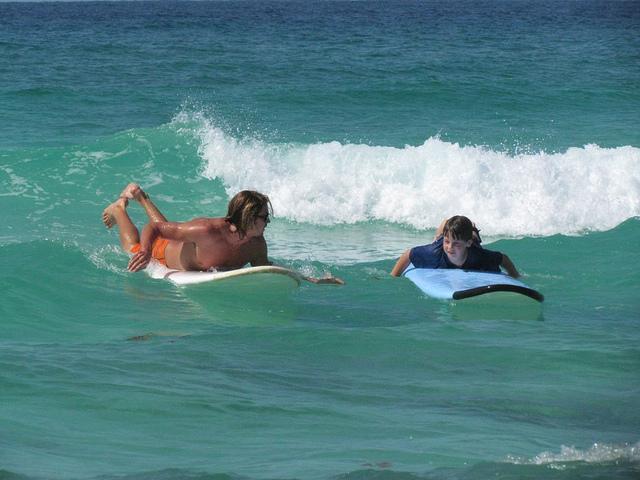How many people are in the water?
Give a very brief answer. 2. How many surfboards are in the photo?
Give a very brief answer. 2. How many people can you see?
Give a very brief answer. 2. How many brown horses are there?
Give a very brief answer. 0. 